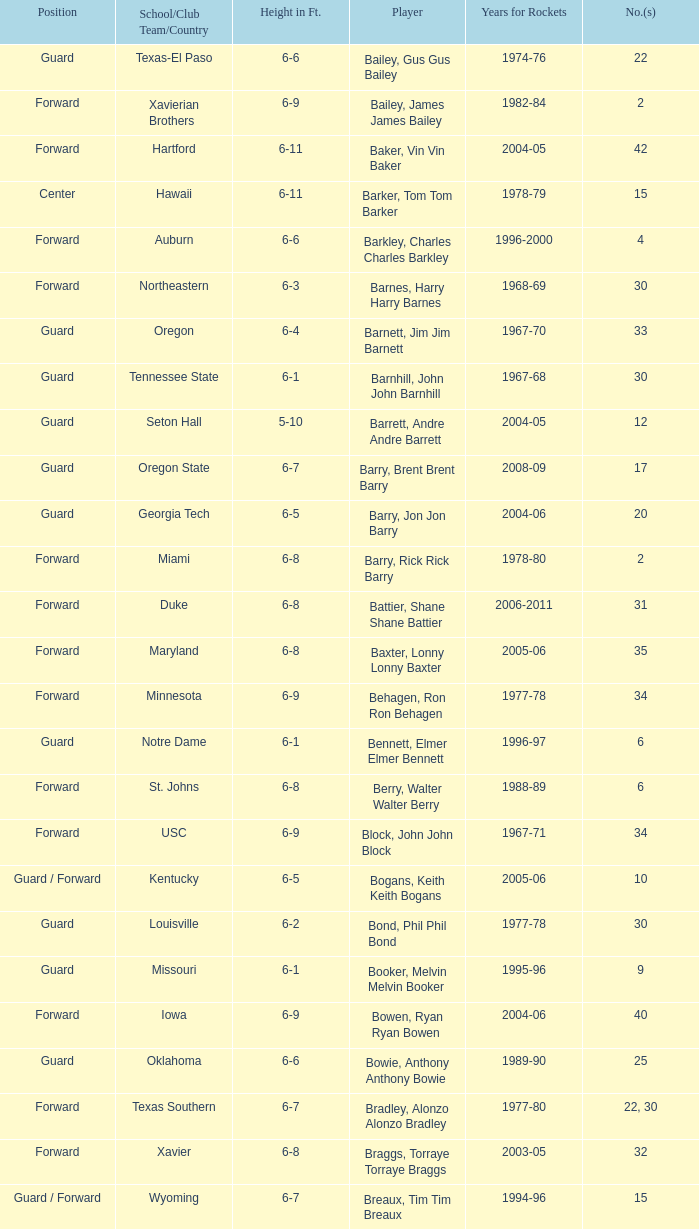What position is number 35 whose height is 6-6? Forward. 